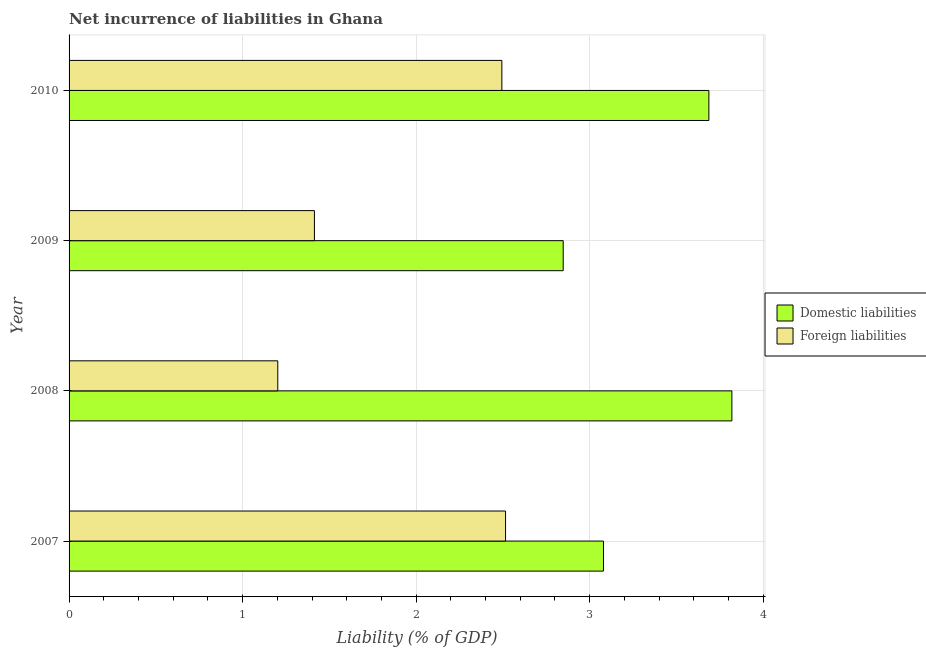How many different coloured bars are there?
Ensure brevity in your answer.  2. How many bars are there on the 1st tick from the bottom?
Give a very brief answer. 2. In how many cases, is the number of bars for a given year not equal to the number of legend labels?
Ensure brevity in your answer.  0. What is the incurrence of foreign liabilities in 2009?
Offer a very short reply. 1.41. Across all years, what is the maximum incurrence of foreign liabilities?
Your answer should be very brief. 2.52. Across all years, what is the minimum incurrence of domestic liabilities?
Ensure brevity in your answer.  2.85. In which year was the incurrence of foreign liabilities minimum?
Ensure brevity in your answer.  2008. What is the total incurrence of foreign liabilities in the graph?
Give a very brief answer. 7.63. What is the difference between the incurrence of foreign liabilities in 2008 and that in 2009?
Your answer should be compact. -0.21. What is the difference between the incurrence of foreign liabilities in 2009 and the incurrence of domestic liabilities in 2010?
Make the answer very short. -2.27. What is the average incurrence of foreign liabilities per year?
Your response must be concise. 1.91. In the year 2010, what is the difference between the incurrence of domestic liabilities and incurrence of foreign liabilities?
Give a very brief answer. 1.19. In how many years, is the incurrence of foreign liabilities greater than 3 %?
Give a very brief answer. 0. What is the ratio of the incurrence of domestic liabilities in 2009 to that in 2010?
Provide a short and direct response. 0.77. Is the incurrence of domestic liabilities in 2008 less than that in 2009?
Ensure brevity in your answer.  No. Is the difference between the incurrence of domestic liabilities in 2008 and 2009 greater than the difference between the incurrence of foreign liabilities in 2008 and 2009?
Provide a succinct answer. Yes. What is the difference between the highest and the second highest incurrence of domestic liabilities?
Your answer should be very brief. 0.13. What is the difference between the highest and the lowest incurrence of domestic liabilities?
Provide a short and direct response. 0.97. What does the 2nd bar from the top in 2010 represents?
Provide a succinct answer. Domestic liabilities. What does the 1st bar from the bottom in 2010 represents?
Ensure brevity in your answer.  Domestic liabilities. How many bars are there?
Your response must be concise. 8. What is the difference between two consecutive major ticks on the X-axis?
Keep it short and to the point. 1. Where does the legend appear in the graph?
Your response must be concise. Center right. How are the legend labels stacked?
Give a very brief answer. Vertical. What is the title of the graph?
Offer a very short reply. Net incurrence of liabilities in Ghana. What is the label or title of the X-axis?
Provide a short and direct response. Liability (% of GDP). What is the Liability (% of GDP) in Domestic liabilities in 2007?
Your response must be concise. 3.08. What is the Liability (% of GDP) of Foreign liabilities in 2007?
Keep it short and to the point. 2.52. What is the Liability (% of GDP) of Domestic liabilities in 2008?
Provide a short and direct response. 3.82. What is the Liability (% of GDP) of Foreign liabilities in 2008?
Offer a terse response. 1.2. What is the Liability (% of GDP) in Domestic liabilities in 2009?
Offer a very short reply. 2.85. What is the Liability (% of GDP) in Foreign liabilities in 2009?
Provide a succinct answer. 1.41. What is the Liability (% of GDP) of Domestic liabilities in 2010?
Provide a succinct answer. 3.69. What is the Liability (% of GDP) of Foreign liabilities in 2010?
Your answer should be very brief. 2.49. Across all years, what is the maximum Liability (% of GDP) of Domestic liabilities?
Offer a terse response. 3.82. Across all years, what is the maximum Liability (% of GDP) in Foreign liabilities?
Give a very brief answer. 2.52. Across all years, what is the minimum Liability (% of GDP) in Domestic liabilities?
Provide a short and direct response. 2.85. Across all years, what is the minimum Liability (% of GDP) in Foreign liabilities?
Provide a succinct answer. 1.2. What is the total Liability (% of GDP) of Domestic liabilities in the graph?
Provide a short and direct response. 13.43. What is the total Liability (% of GDP) in Foreign liabilities in the graph?
Provide a short and direct response. 7.63. What is the difference between the Liability (% of GDP) of Domestic liabilities in 2007 and that in 2008?
Provide a short and direct response. -0.74. What is the difference between the Liability (% of GDP) of Foreign liabilities in 2007 and that in 2008?
Give a very brief answer. 1.31. What is the difference between the Liability (% of GDP) of Domestic liabilities in 2007 and that in 2009?
Provide a short and direct response. 0.23. What is the difference between the Liability (% of GDP) of Foreign liabilities in 2007 and that in 2009?
Give a very brief answer. 1.1. What is the difference between the Liability (% of GDP) of Domestic liabilities in 2007 and that in 2010?
Provide a short and direct response. -0.61. What is the difference between the Liability (% of GDP) in Foreign liabilities in 2007 and that in 2010?
Offer a very short reply. 0.02. What is the difference between the Liability (% of GDP) in Domestic liabilities in 2008 and that in 2009?
Offer a terse response. 0.97. What is the difference between the Liability (% of GDP) in Foreign liabilities in 2008 and that in 2009?
Your answer should be very brief. -0.21. What is the difference between the Liability (% of GDP) in Domestic liabilities in 2008 and that in 2010?
Give a very brief answer. 0.13. What is the difference between the Liability (% of GDP) of Foreign liabilities in 2008 and that in 2010?
Ensure brevity in your answer.  -1.29. What is the difference between the Liability (% of GDP) of Domestic liabilities in 2009 and that in 2010?
Your response must be concise. -0.84. What is the difference between the Liability (% of GDP) in Foreign liabilities in 2009 and that in 2010?
Give a very brief answer. -1.08. What is the difference between the Liability (% of GDP) of Domestic liabilities in 2007 and the Liability (% of GDP) of Foreign liabilities in 2008?
Keep it short and to the point. 1.88. What is the difference between the Liability (% of GDP) of Domestic liabilities in 2007 and the Liability (% of GDP) of Foreign liabilities in 2009?
Your response must be concise. 1.67. What is the difference between the Liability (% of GDP) in Domestic liabilities in 2007 and the Liability (% of GDP) in Foreign liabilities in 2010?
Your answer should be compact. 0.59. What is the difference between the Liability (% of GDP) of Domestic liabilities in 2008 and the Liability (% of GDP) of Foreign liabilities in 2009?
Keep it short and to the point. 2.41. What is the difference between the Liability (% of GDP) of Domestic liabilities in 2008 and the Liability (% of GDP) of Foreign liabilities in 2010?
Your response must be concise. 1.33. What is the difference between the Liability (% of GDP) of Domestic liabilities in 2009 and the Liability (% of GDP) of Foreign liabilities in 2010?
Offer a terse response. 0.35. What is the average Liability (% of GDP) in Domestic liabilities per year?
Your response must be concise. 3.36. What is the average Liability (% of GDP) in Foreign liabilities per year?
Ensure brevity in your answer.  1.91. In the year 2007, what is the difference between the Liability (% of GDP) in Domestic liabilities and Liability (% of GDP) in Foreign liabilities?
Provide a short and direct response. 0.56. In the year 2008, what is the difference between the Liability (% of GDP) in Domestic liabilities and Liability (% of GDP) in Foreign liabilities?
Your response must be concise. 2.62. In the year 2009, what is the difference between the Liability (% of GDP) of Domestic liabilities and Liability (% of GDP) of Foreign liabilities?
Give a very brief answer. 1.43. In the year 2010, what is the difference between the Liability (% of GDP) of Domestic liabilities and Liability (% of GDP) of Foreign liabilities?
Your response must be concise. 1.19. What is the ratio of the Liability (% of GDP) in Domestic liabilities in 2007 to that in 2008?
Keep it short and to the point. 0.81. What is the ratio of the Liability (% of GDP) in Foreign liabilities in 2007 to that in 2008?
Your answer should be compact. 2.09. What is the ratio of the Liability (% of GDP) of Domestic liabilities in 2007 to that in 2009?
Keep it short and to the point. 1.08. What is the ratio of the Liability (% of GDP) in Foreign liabilities in 2007 to that in 2009?
Give a very brief answer. 1.78. What is the ratio of the Liability (% of GDP) of Domestic liabilities in 2007 to that in 2010?
Your response must be concise. 0.84. What is the ratio of the Liability (% of GDP) in Foreign liabilities in 2007 to that in 2010?
Offer a very short reply. 1.01. What is the ratio of the Liability (% of GDP) in Domestic liabilities in 2008 to that in 2009?
Provide a short and direct response. 1.34. What is the ratio of the Liability (% of GDP) in Foreign liabilities in 2008 to that in 2009?
Your answer should be compact. 0.85. What is the ratio of the Liability (% of GDP) of Domestic liabilities in 2008 to that in 2010?
Provide a succinct answer. 1.04. What is the ratio of the Liability (% of GDP) in Foreign liabilities in 2008 to that in 2010?
Give a very brief answer. 0.48. What is the ratio of the Liability (% of GDP) in Domestic liabilities in 2009 to that in 2010?
Your answer should be very brief. 0.77. What is the ratio of the Liability (% of GDP) of Foreign liabilities in 2009 to that in 2010?
Keep it short and to the point. 0.57. What is the difference between the highest and the second highest Liability (% of GDP) of Domestic liabilities?
Make the answer very short. 0.13. What is the difference between the highest and the second highest Liability (% of GDP) in Foreign liabilities?
Your answer should be compact. 0.02. What is the difference between the highest and the lowest Liability (% of GDP) in Domestic liabilities?
Make the answer very short. 0.97. What is the difference between the highest and the lowest Liability (% of GDP) of Foreign liabilities?
Your response must be concise. 1.31. 